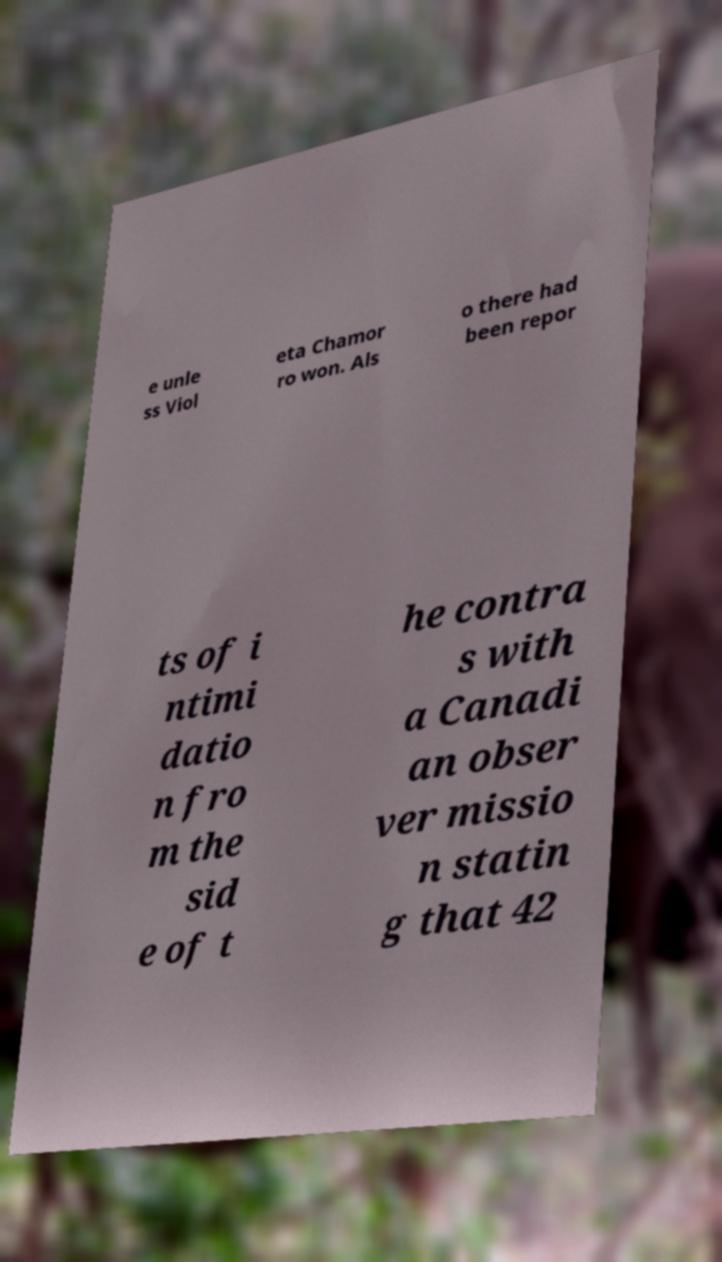Please identify and transcribe the text found in this image. e unle ss Viol eta Chamor ro won. Als o there had been repor ts of i ntimi datio n fro m the sid e of t he contra s with a Canadi an obser ver missio n statin g that 42 